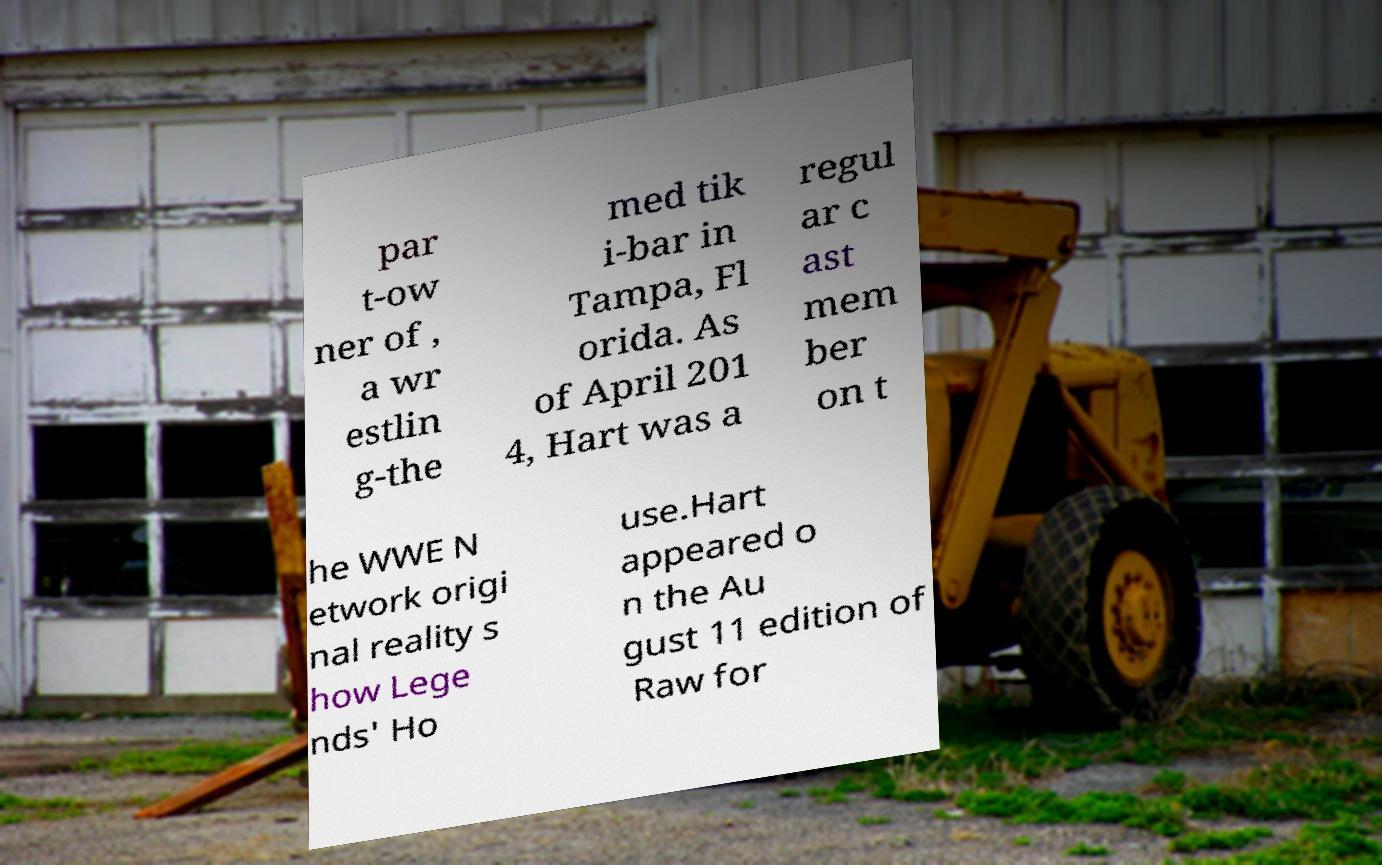I need the written content from this picture converted into text. Can you do that? par t-ow ner of , a wr estlin g-the med tik i-bar in Tampa, Fl orida. As of April 201 4, Hart was a regul ar c ast mem ber on t he WWE N etwork origi nal reality s how Lege nds' Ho use.Hart appeared o n the Au gust 11 edition of Raw for 